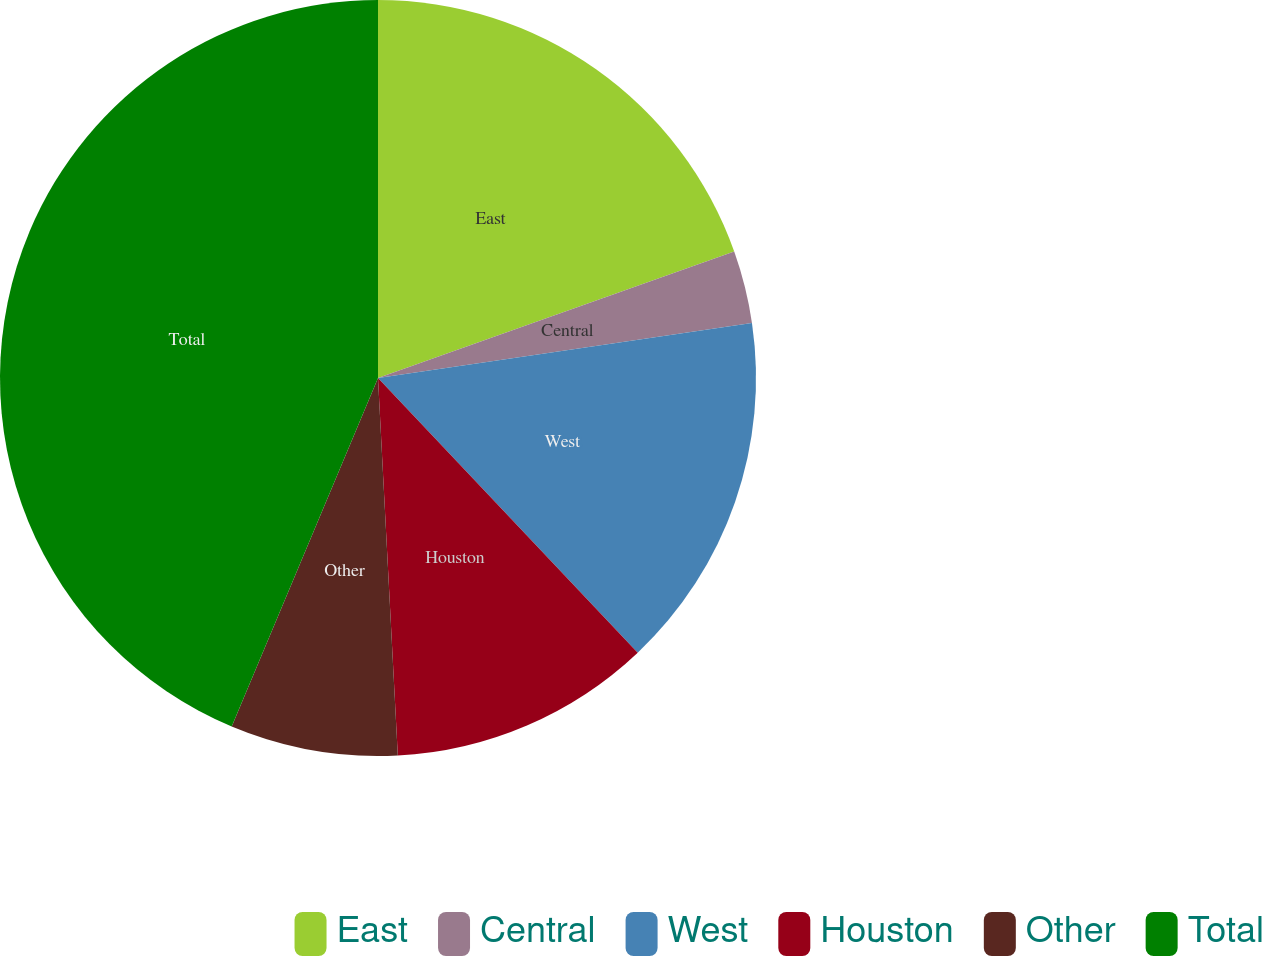Convert chart. <chart><loc_0><loc_0><loc_500><loc_500><pie_chart><fcel>East<fcel>Central<fcel>West<fcel>Houston<fcel>Other<fcel>Total<nl><fcel>19.57%<fcel>3.1%<fcel>15.27%<fcel>11.22%<fcel>7.16%<fcel>43.67%<nl></chart> 